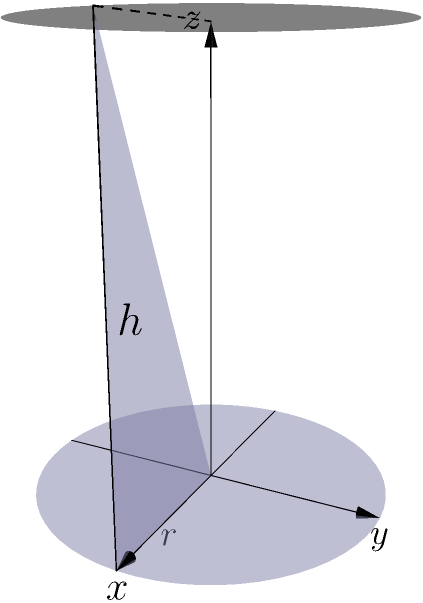A cylindrical water tank is being designed for a wildlife preservation project in Triglav National Park. The tank has a radius of 2 meters and a height of 5 meters. Calculate the volume of water the tank can hold, rounded to the nearest cubic meter. To calculate the volume of a cylindrical tank, we use the formula:

$$V = \pi r^2 h$$

Where:
$V$ = volume
$r$ = radius
$h$ = height

Given:
$r = 2$ meters
$h = 5$ meters

Step 1: Substitute the values into the formula
$$V = \pi (2\text{ m})^2 (5\text{ m})$$

Step 2: Calculate the square of the radius
$$V = \pi (4\text{ m}^2) (5\text{ m})$$

Step 3: Multiply the values
$$V = 20\pi\text{ m}^3$$

Step 4: Calculate the final value (using $\pi \approx 3.14159$)
$$V \approx 20 \times 3.14159\text{ m}^3 = 62.8318\text{ m}^3$$

Step 5: Round to the nearest cubic meter
$$V \approx 63\text{ m}^3$$

Therefore, the cylindrical water tank can hold approximately 63 cubic meters of water.
Answer: 63 m³ 